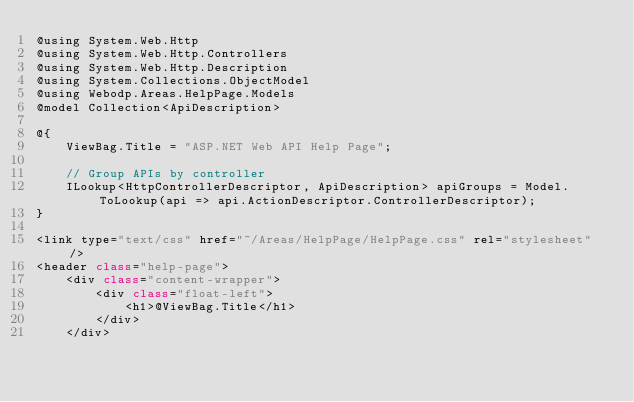Convert code to text. <code><loc_0><loc_0><loc_500><loc_500><_C#_>@using System.Web.Http
@using System.Web.Http.Controllers
@using System.Web.Http.Description
@using System.Collections.ObjectModel
@using Webodp.Areas.HelpPage.Models
@model Collection<ApiDescription>

@{
    ViewBag.Title = "ASP.NET Web API Help Page";

    // Group APIs by controller
    ILookup<HttpControllerDescriptor, ApiDescription> apiGroups = Model.ToLookup(api => api.ActionDescriptor.ControllerDescriptor);
}

<link type="text/css" href="~/Areas/HelpPage/HelpPage.css" rel="stylesheet" />
<header class="help-page">
    <div class="content-wrapper">
        <div class="float-left">
            <h1>@ViewBag.Title</h1>
        </div>
    </div></code> 